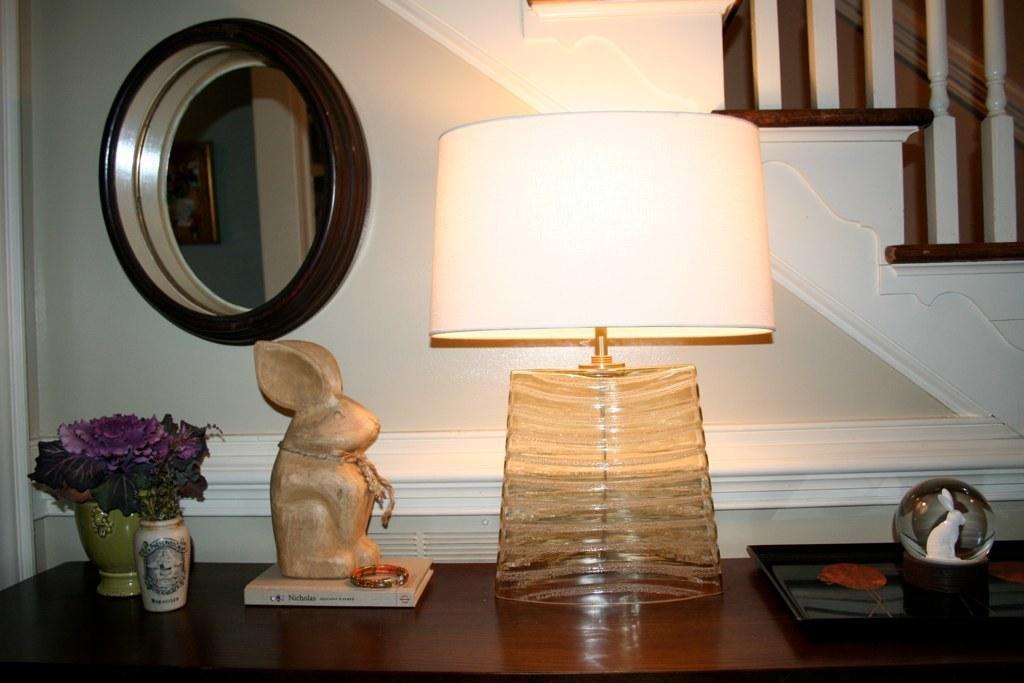Describe this image in one or two sentences. In this image we can see a lamp, statue, flowers on plants in pots and some objects placed on the table. In the background, we can see staircase, wooden poles, photo frame on the wall and a window. 